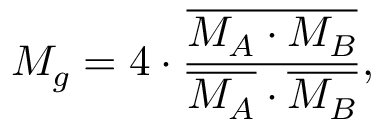<formula> <loc_0><loc_0><loc_500><loc_500>M _ { g } = 4 \cdot \frac { \overline { { M _ { A } \cdot M _ { B } } } } { \overline { { M _ { A } } } \cdot \overline { { M _ { B } } } } ,</formula> 